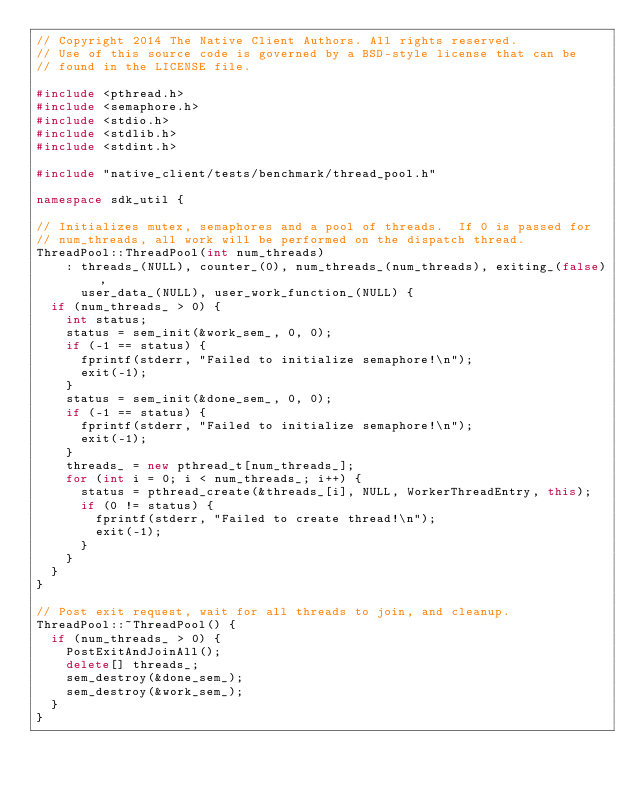<code> <loc_0><loc_0><loc_500><loc_500><_C++_>// Copyright 2014 The Native Client Authors. All rights reserved.
// Use of this source code is governed by a BSD-style license that can be
// found in the LICENSE file.

#include <pthread.h>
#include <semaphore.h>
#include <stdio.h>
#include <stdlib.h>
#include <stdint.h>

#include "native_client/tests/benchmark/thread_pool.h"

namespace sdk_util {

// Initializes mutex, semaphores and a pool of threads.  If 0 is passed for
// num_threads, all work will be performed on the dispatch thread.
ThreadPool::ThreadPool(int num_threads)
    : threads_(NULL), counter_(0), num_threads_(num_threads), exiting_(false),
      user_data_(NULL), user_work_function_(NULL) {
  if (num_threads_ > 0) {
    int status;
    status = sem_init(&work_sem_, 0, 0);
    if (-1 == status) {
      fprintf(stderr, "Failed to initialize semaphore!\n");
      exit(-1);
    }
    status = sem_init(&done_sem_, 0, 0);
    if (-1 == status) {
      fprintf(stderr, "Failed to initialize semaphore!\n");
      exit(-1);
    }
    threads_ = new pthread_t[num_threads_];
    for (int i = 0; i < num_threads_; i++) {
      status = pthread_create(&threads_[i], NULL, WorkerThreadEntry, this);
      if (0 != status) {
        fprintf(stderr, "Failed to create thread!\n");
        exit(-1);
      }
    }
  }
}

// Post exit request, wait for all threads to join, and cleanup.
ThreadPool::~ThreadPool() {
  if (num_threads_ > 0) {
    PostExitAndJoinAll();
    delete[] threads_;
    sem_destroy(&done_sem_);
    sem_destroy(&work_sem_);
  }
}
</code> 